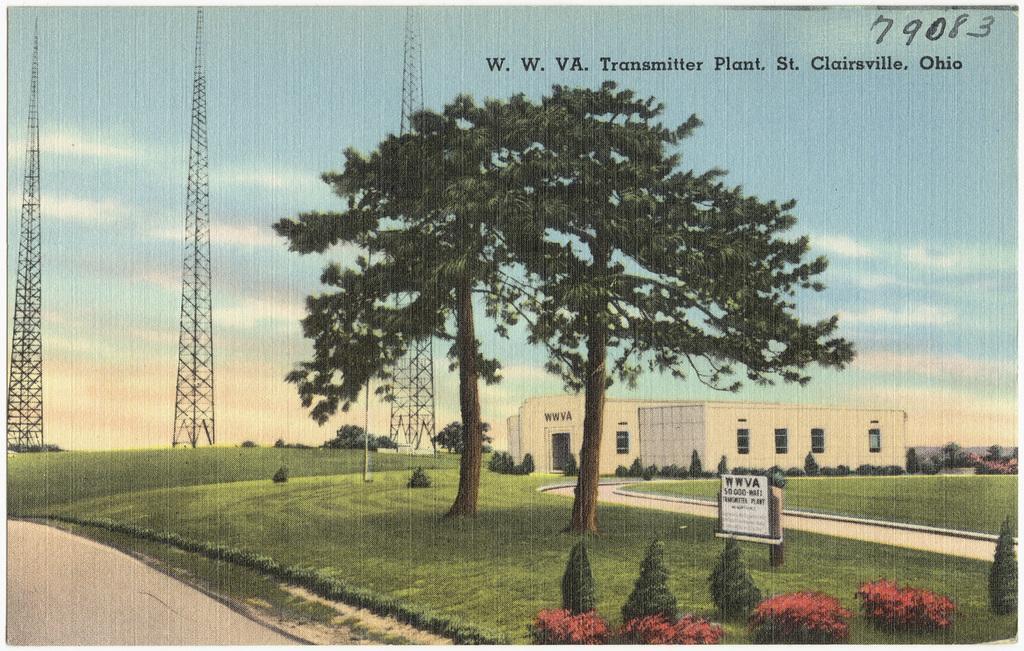How would you summarize this image in a sentence or two? This is a poster having an image, a text and numbers. In the image, there are trees, plants, buildings, a signboard, roads and grass on the ground and there are clouds in the blue sky. 